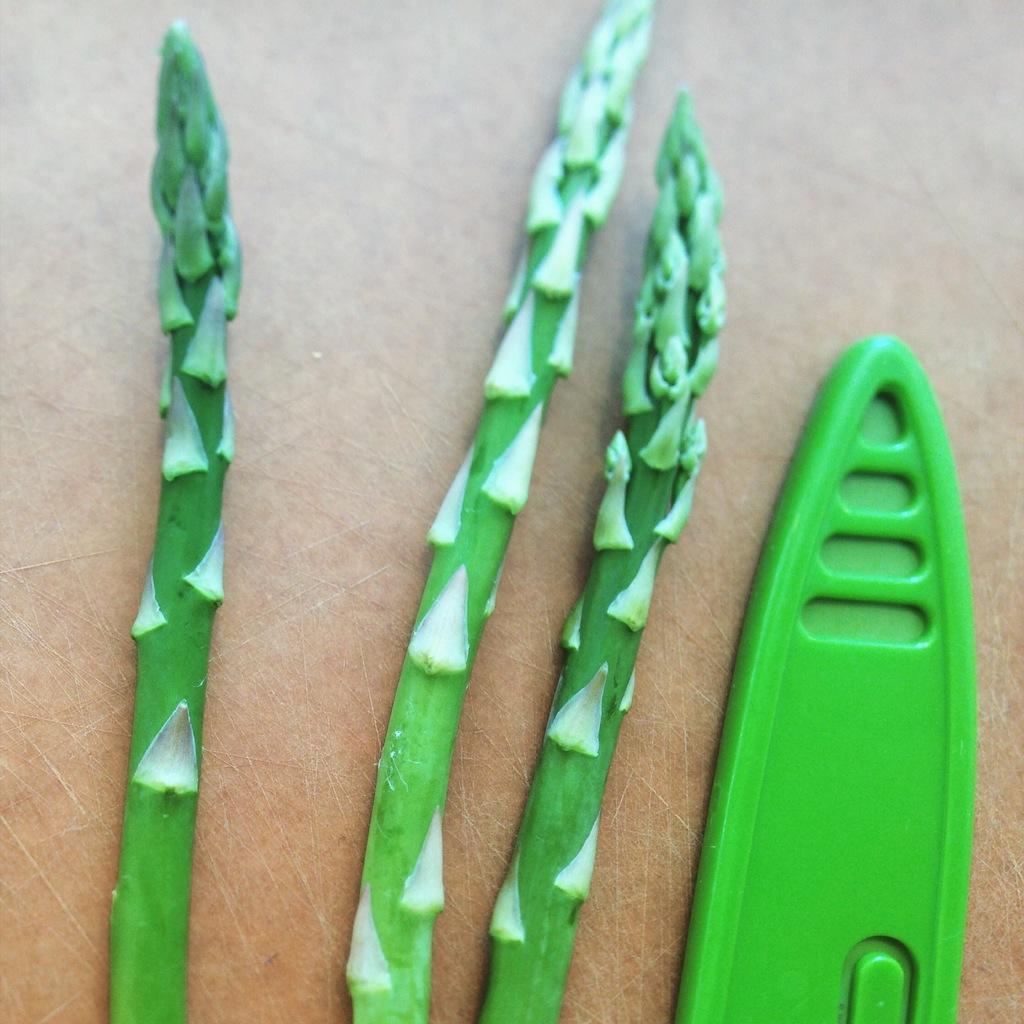Describe this image in one or two sentences. In this picture, it seems to be the stems, which are green in color in the center of the image, it seems to be a toy surfing boat on the right side of the image. 